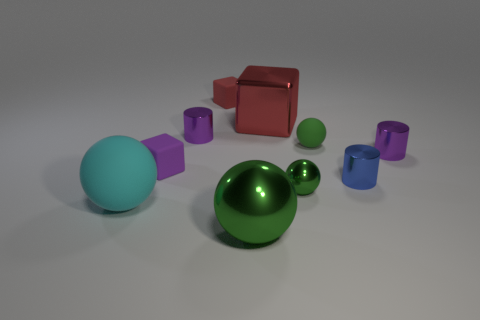Subtract all tiny blue metallic cylinders. How many cylinders are left? 2 Subtract all blue cylinders. How many cylinders are left? 2 Subtract all spheres. How many objects are left? 6 Subtract 3 blocks. How many blocks are left? 0 Subtract 0 green cylinders. How many objects are left? 10 Subtract all purple balls. Subtract all red cylinders. How many balls are left? 4 Subtract all green blocks. How many red cylinders are left? 0 Subtract all tiny cyan objects. Subtract all metal blocks. How many objects are left? 9 Add 1 small green metallic spheres. How many small green metallic spheres are left? 2 Add 10 large blue rubber things. How many large blue rubber things exist? 10 